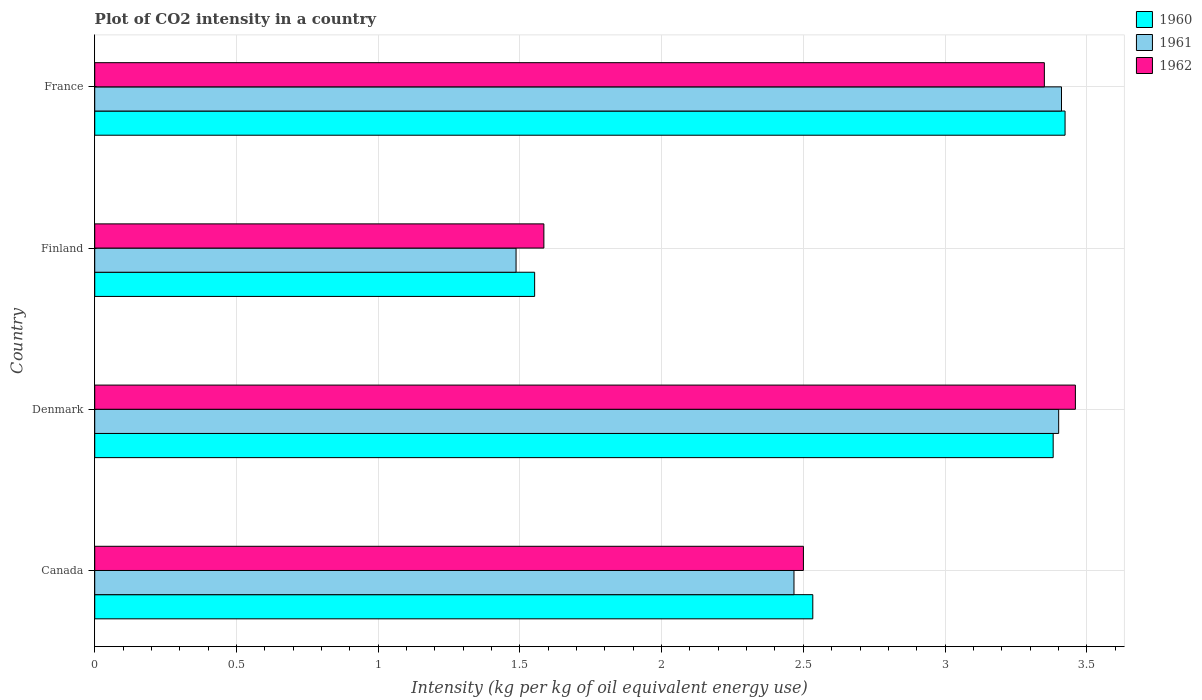How many different coloured bars are there?
Your answer should be very brief. 3. Are the number of bars per tick equal to the number of legend labels?
Ensure brevity in your answer.  Yes. What is the CO2 intensity in in 1960 in Denmark?
Your response must be concise. 3.38. Across all countries, what is the maximum CO2 intensity in in 1962?
Ensure brevity in your answer.  3.46. Across all countries, what is the minimum CO2 intensity in in 1960?
Your answer should be very brief. 1.55. In which country was the CO2 intensity in in 1960 maximum?
Give a very brief answer. France. What is the total CO2 intensity in in 1961 in the graph?
Make the answer very short. 10.77. What is the difference between the CO2 intensity in in 1962 in Canada and that in Denmark?
Give a very brief answer. -0.96. What is the difference between the CO2 intensity in in 1962 in Denmark and the CO2 intensity in in 1961 in Canada?
Provide a short and direct response. 0.99. What is the average CO2 intensity in in 1962 per country?
Your answer should be compact. 2.72. What is the difference between the CO2 intensity in in 1962 and CO2 intensity in in 1960 in Denmark?
Give a very brief answer. 0.08. In how many countries, is the CO2 intensity in in 1960 greater than 0.1 kg?
Your answer should be very brief. 4. What is the ratio of the CO2 intensity in in 1961 in Finland to that in France?
Make the answer very short. 0.44. Is the difference between the CO2 intensity in in 1962 in Finland and France greater than the difference between the CO2 intensity in in 1960 in Finland and France?
Offer a terse response. Yes. What is the difference between the highest and the second highest CO2 intensity in in 1960?
Provide a short and direct response. 0.04. What is the difference between the highest and the lowest CO2 intensity in in 1961?
Keep it short and to the point. 1.92. What does the 1st bar from the bottom in Canada represents?
Offer a terse response. 1960. Is it the case that in every country, the sum of the CO2 intensity in in 1960 and CO2 intensity in in 1961 is greater than the CO2 intensity in in 1962?
Offer a very short reply. Yes. What is the difference between two consecutive major ticks on the X-axis?
Your answer should be compact. 0.5. Are the values on the major ticks of X-axis written in scientific E-notation?
Make the answer very short. No. Does the graph contain any zero values?
Give a very brief answer. No. How many legend labels are there?
Your answer should be very brief. 3. What is the title of the graph?
Provide a succinct answer. Plot of CO2 intensity in a country. Does "2015" appear as one of the legend labels in the graph?
Keep it short and to the point. No. What is the label or title of the X-axis?
Offer a terse response. Intensity (kg per kg of oil equivalent energy use). What is the label or title of the Y-axis?
Keep it short and to the point. Country. What is the Intensity (kg per kg of oil equivalent energy use) in 1960 in Canada?
Offer a terse response. 2.53. What is the Intensity (kg per kg of oil equivalent energy use) of 1961 in Canada?
Your answer should be very brief. 2.47. What is the Intensity (kg per kg of oil equivalent energy use) of 1962 in Canada?
Make the answer very short. 2.5. What is the Intensity (kg per kg of oil equivalent energy use) in 1960 in Denmark?
Your answer should be very brief. 3.38. What is the Intensity (kg per kg of oil equivalent energy use) of 1961 in Denmark?
Your answer should be compact. 3.4. What is the Intensity (kg per kg of oil equivalent energy use) of 1962 in Denmark?
Your answer should be very brief. 3.46. What is the Intensity (kg per kg of oil equivalent energy use) of 1960 in Finland?
Your response must be concise. 1.55. What is the Intensity (kg per kg of oil equivalent energy use) of 1961 in Finland?
Provide a succinct answer. 1.49. What is the Intensity (kg per kg of oil equivalent energy use) in 1962 in Finland?
Ensure brevity in your answer.  1.58. What is the Intensity (kg per kg of oil equivalent energy use) of 1960 in France?
Provide a short and direct response. 3.42. What is the Intensity (kg per kg of oil equivalent energy use) in 1961 in France?
Provide a succinct answer. 3.41. What is the Intensity (kg per kg of oil equivalent energy use) in 1962 in France?
Ensure brevity in your answer.  3.35. Across all countries, what is the maximum Intensity (kg per kg of oil equivalent energy use) in 1960?
Offer a terse response. 3.42. Across all countries, what is the maximum Intensity (kg per kg of oil equivalent energy use) in 1961?
Your response must be concise. 3.41. Across all countries, what is the maximum Intensity (kg per kg of oil equivalent energy use) in 1962?
Give a very brief answer. 3.46. Across all countries, what is the minimum Intensity (kg per kg of oil equivalent energy use) in 1960?
Your response must be concise. 1.55. Across all countries, what is the minimum Intensity (kg per kg of oil equivalent energy use) in 1961?
Provide a short and direct response. 1.49. Across all countries, what is the minimum Intensity (kg per kg of oil equivalent energy use) of 1962?
Give a very brief answer. 1.58. What is the total Intensity (kg per kg of oil equivalent energy use) in 1960 in the graph?
Your answer should be very brief. 10.89. What is the total Intensity (kg per kg of oil equivalent energy use) of 1961 in the graph?
Offer a very short reply. 10.77. What is the total Intensity (kg per kg of oil equivalent energy use) of 1962 in the graph?
Your answer should be very brief. 10.9. What is the difference between the Intensity (kg per kg of oil equivalent energy use) in 1960 in Canada and that in Denmark?
Your response must be concise. -0.85. What is the difference between the Intensity (kg per kg of oil equivalent energy use) in 1961 in Canada and that in Denmark?
Your answer should be very brief. -0.93. What is the difference between the Intensity (kg per kg of oil equivalent energy use) in 1962 in Canada and that in Denmark?
Provide a short and direct response. -0.96. What is the difference between the Intensity (kg per kg of oil equivalent energy use) in 1960 in Canada and that in Finland?
Keep it short and to the point. 0.98. What is the difference between the Intensity (kg per kg of oil equivalent energy use) of 1961 in Canada and that in Finland?
Offer a very short reply. 0.98. What is the difference between the Intensity (kg per kg of oil equivalent energy use) of 1962 in Canada and that in Finland?
Your response must be concise. 0.92. What is the difference between the Intensity (kg per kg of oil equivalent energy use) in 1960 in Canada and that in France?
Your answer should be very brief. -0.89. What is the difference between the Intensity (kg per kg of oil equivalent energy use) in 1961 in Canada and that in France?
Your answer should be compact. -0.94. What is the difference between the Intensity (kg per kg of oil equivalent energy use) in 1962 in Canada and that in France?
Your answer should be compact. -0.85. What is the difference between the Intensity (kg per kg of oil equivalent energy use) in 1960 in Denmark and that in Finland?
Ensure brevity in your answer.  1.83. What is the difference between the Intensity (kg per kg of oil equivalent energy use) of 1961 in Denmark and that in Finland?
Provide a succinct answer. 1.91. What is the difference between the Intensity (kg per kg of oil equivalent energy use) in 1962 in Denmark and that in Finland?
Provide a short and direct response. 1.88. What is the difference between the Intensity (kg per kg of oil equivalent energy use) of 1960 in Denmark and that in France?
Offer a very short reply. -0.04. What is the difference between the Intensity (kg per kg of oil equivalent energy use) in 1961 in Denmark and that in France?
Provide a succinct answer. -0.01. What is the difference between the Intensity (kg per kg of oil equivalent energy use) of 1962 in Denmark and that in France?
Your answer should be compact. 0.11. What is the difference between the Intensity (kg per kg of oil equivalent energy use) in 1960 in Finland and that in France?
Offer a terse response. -1.87. What is the difference between the Intensity (kg per kg of oil equivalent energy use) of 1961 in Finland and that in France?
Offer a terse response. -1.92. What is the difference between the Intensity (kg per kg of oil equivalent energy use) of 1962 in Finland and that in France?
Provide a succinct answer. -1.77. What is the difference between the Intensity (kg per kg of oil equivalent energy use) in 1960 in Canada and the Intensity (kg per kg of oil equivalent energy use) in 1961 in Denmark?
Your answer should be very brief. -0.87. What is the difference between the Intensity (kg per kg of oil equivalent energy use) in 1960 in Canada and the Intensity (kg per kg of oil equivalent energy use) in 1962 in Denmark?
Give a very brief answer. -0.93. What is the difference between the Intensity (kg per kg of oil equivalent energy use) in 1961 in Canada and the Intensity (kg per kg of oil equivalent energy use) in 1962 in Denmark?
Offer a terse response. -0.99. What is the difference between the Intensity (kg per kg of oil equivalent energy use) in 1960 in Canada and the Intensity (kg per kg of oil equivalent energy use) in 1961 in Finland?
Your response must be concise. 1.05. What is the difference between the Intensity (kg per kg of oil equivalent energy use) of 1960 in Canada and the Intensity (kg per kg of oil equivalent energy use) of 1962 in Finland?
Give a very brief answer. 0.95. What is the difference between the Intensity (kg per kg of oil equivalent energy use) of 1961 in Canada and the Intensity (kg per kg of oil equivalent energy use) of 1962 in Finland?
Your response must be concise. 0.88. What is the difference between the Intensity (kg per kg of oil equivalent energy use) in 1960 in Canada and the Intensity (kg per kg of oil equivalent energy use) in 1961 in France?
Your answer should be compact. -0.88. What is the difference between the Intensity (kg per kg of oil equivalent energy use) in 1960 in Canada and the Intensity (kg per kg of oil equivalent energy use) in 1962 in France?
Your answer should be very brief. -0.82. What is the difference between the Intensity (kg per kg of oil equivalent energy use) of 1961 in Canada and the Intensity (kg per kg of oil equivalent energy use) of 1962 in France?
Offer a very short reply. -0.88. What is the difference between the Intensity (kg per kg of oil equivalent energy use) in 1960 in Denmark and the Intensity (kg per kg of oil equivalent energy use) in 1961 in Finland?
Provide a short and direct response. 1.9. What is the difference between the Intensity (kg per kg of oil equivalent energy use) in 1960 in Denmark and the Intensity (kg per kg of oil equivalent energy use) in 1962 in Finland?
Make the answer very short. 1.8. What is the difference between the Intensity (kg per kg of oil equivalent energy use) in 1961 in Denmark and the Intensity (kg per kg of oil equivalent energy use) in 1962 in Finland?
Keep it short and to the point. 1.82. What is the difference between the Intensity (kg per kg of oil equivalent energy use) in 1960 in Denmark and the Intensity (kg per kg of oil equivalent energy use) in 1961 in France?
Your response must be concise. -0.03. What is the difference between the Intensity (kg per kg of oil equivalent energy use) of 1960 in Denmark and the Intensity (kg per kg of oil equivalent energy use) of 1962 in France?
Offer a terse response. 0.03. What is the difference between the Intensity (kg per kg of oil equivalent energy use) of 1961 in Denmark and the Intensity (kg per kg of oil equivalent energy use) of 1962 in France?
Your response must be concise. 0.05. What is the difference between the Intensity (kg per kg of oil equivalent energy use) in 1960 in Finland and the Intensity (kg per kg of oil equivalent energy use) in 1961 in France?
Offer a very short reply. -1.86. What is the difference between the Intensity (kg per kg of oil equivalent energy use) in 1960 in Finland and the Intensity (kg per kg of oil equivalent energy use) in 1962 in France?
Provide a short and direct response. -1.8. What is the difference between the Intensity (kg per kg of oil equivalent energy use) in 1961 in Finland and the Intensity (kg per kg of oil equivalent energy use) in 1962 in France?
Give a very brief answer. -1.86. What is the average Intensity (kg per kg of oil equivalent energy use) in 1960 per country?
Your response must be concise. 2.72. What is the average Intensity (kg per kg of oil equivalent energy use) in 1961 per country?
Offer a very short reply. 2.69. What is the average Intensity (kg per kg of oil equivalent energy use) in 1962 per country?
Your answer should be compact. 2.72. What is the difference between the Intensity (kg per kg of oil equivalent energy use) of 1960 and Intensity (kg per kg of oil equivalent energy use) of 1961 in Canada?
Offer a terse response. 0.07. What is the difference between the Intensity (kg per kg of oil equivalent energy use) of 1960 and Intensity (kg per kg of oil equivalent energy use) of 1962 in Canada?
Your answer should be compact. 0.03. What is the difference between the Intensity (kg per kg of oil equivalent energy use) of 1961 and Intensity (kg per kg of oil equivalent energy use) of 1962 in Canada?
Ensure brevity in your answer.  -0.03. What is the difference between the Intensity (kg per kg of oil equivalent energy use) in 1960 and Intensity (kg per kg of oil equivalent energy use) in 1961 in Denmark?
Offer a very short reply. -0.02. What is the difference between the Intensity (kg per kg of oil equivalent energy use) of 1960 and Intensity (kg per kg of oil equivalent energy use) of 1962 in Denmark?
Provide a succinct answer. -0.08. What is the difference between the Intensity (kg per kg of oil equivalent energy use) of 1961 and Intensity (kg per kg of oil equivalent energy use) of 1962 in Denmark?
Your response must be concise. -0.06. What is the difference between the Intensity (kg per kg of oil equivalent energy use) of 1960 and Intensity (kg per kg of oil equivalent energy use) of 1961 in Finland?
Give a very brief answer. 0.07. What is the difference between the Intensity (kg per kg of oil equivalent energy use) of 1960 and Intensity (kg per kg of oil equivalent energy use) of 1962 in Finland?
Provide a succinct answer. -0.03. What is the difference between the Intensity (kg per kg of oil equivalent energy use) in 1961 and Intensity (kg per kg of oil equivalent energy use) in 1962 in Finland?
Provide a succinct answer. -0.1. What is the difference between the Intensity (kg per kg of oil equivalent energy use) of 1960 and Intensity (kg per kg of oil equivalent energy use) of 1961 in France?
Give a very brief answer. 0.01. What is the difference between the Intensity (kg per kg of oil equivalent energy use) of 1960 and Intensity (kg per kg of oil equivalent energy use) of 1962 in France?
Give a very brief answer. 0.07. What is the difference between the Intensity (kg per kg of oil equivalent energy use) in 1961 and Intensity (kg per kg of oil equivalent energy use) in 1962 in France?
Your answer should be compact. 0.06. What is the ratio of the Intensity (kg per kg of oil equivalent energy use) of 1960 in Canada to that in Denmark?
Your answer should be very brief. 0.75. What is the ratio of the Intensity (kg per kg of oil equivalent energy use) in 1961 in Canada to that in Denmark?
Offer a very short reply. 0.73. What is the ratio of the Intensity (kg per kg of oil equivalent energy use) of 1962 in Canada to that in Denmark?
Keep it short and to the point. 0.72. What is the ratio of the Intensity (kg per kg of oil equivalent energy use) in 1960 in Canada to that in Finland?
Provide a succinct answer. 1.63. What is the ratio of the Intensity (kg per kg of oil equivalent energy use) of 1961 in Canada to that in Finland?
Offer a very short reply. 1.66. What is the ratio of the Intensity (kg per kg of oil equivalent energy use) of 1962 in Canada to that in Finland?
Provide a succinct answer. 1.58. What is the ratio of the Intensity (kg per kg of oil equivalent energy use) of 1960 in Canada to that in France?
Provide a succinct answer. 0.74. What is the ratio of the Intensity (kg per kg of oil equivalent energy use) in 1961 in Canada to that in France?
Offer a terse response. 0.72. What is the ratio of the Intensity (kg per kg of oil equivalent energy use) of 1962 in Canada to that in France?
Provide a succinct answer. 0.75. What is the ratio of the Intensity (kg per kg of oil equivalent energy use) of 1960 in Denmark to that in Finland?
Provide a short and direct response. 2.18. What is the ratio of the Intensity (kg per kg of oil equivalent energy use) in 1961 in Denmark to that in Finland?
Give a very brief answer. 2.29. What is the ratio of the Intensity (kg per kg of oil equivalent energy use) of 1962 in Denmark to that in Finland?
Your answer should be compact. 2.18. What is the ratio of the Intensity (kg per kg of oil equivalent energy use) in 1961 in Denmark to that in France?
Keep it short and to the point. 1. What is the ratio of the Intensity (kg per kg of oil equivalent energy use) in 1962 in Denmark to that in France?
Your answer should be compact. 1.03. What is the ratio of the Intensity (kg per kg of oil equivalent energy use) in 1960 in Finland to that in France?
Provide a succinct answer. 0.45. What is the ratio of the Intensity (kg per kg of oil equivalent energy use) of 1961 in Finland to that in France?
Your answer should be very brief. 0.44. What is the ratio of the Intensity (kg per kg of oil equivalent energy use) of 1962 in Finland to that in France?
Make the answer very short. 0.47. What is the difference between the highest and the second highest Intensity (kg per kg of oil equivalent energy use) of 1960?
Offer a terse response. 0.04. What is the difference between the highest and the second highest Intensity (kg per kg of oil equivalent energy use) of 1961?
Offer a very short reply. 0.01. What is the difference between the highest and the second highest Intensity (kg per kg of oil equivalent energy use) of 1962?
Your answer should be compact. 0.11. What is the difference between the highest and the lowest Intensity (kg per kg of oil equivalent energy use) of 1960?
Offer a terse response. 1.87. What is the difference between the highest and the lowest Intensity (kg per kg of oil equivalent energy use) in 1961?
Offer a very short reply. 1.92. What is the difference between the highest and the lowest Intensity (kg per kg of oil equivalent energy use) in 1962?
Give a very brief answer. 1.88. 